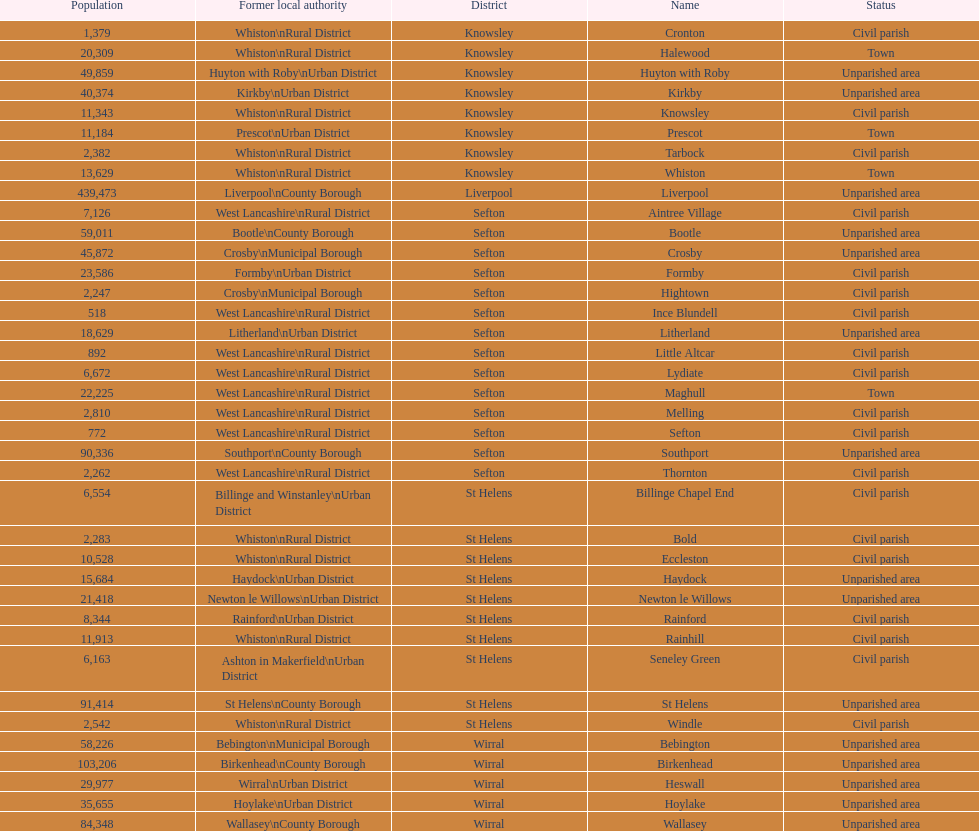How many civil parishes have population counts of at least 10,000? 4. 